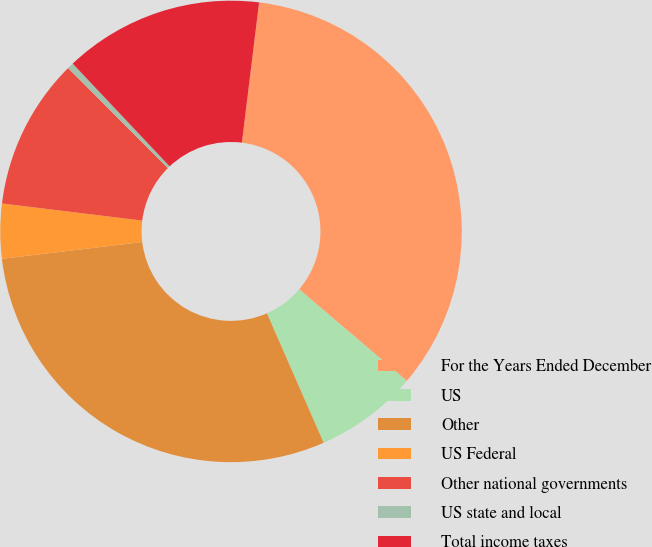Convert chart to OTSL. <chart><loc_0><loc_0><loc_500><loc_500><pie_chart><fcel>For the Years Ended December<fcel>US<fcel>Other<fcel>US Federal<fcel>Other national governments<fcel>US state and local<fcel>Total income taxes<nl><fcel>34.28%<fcel>7.21%<fcel>29.68%<fcel>3.83%<fcel>10.59%<fcel>0.44%<fcel>13.98%<nl></chart> 